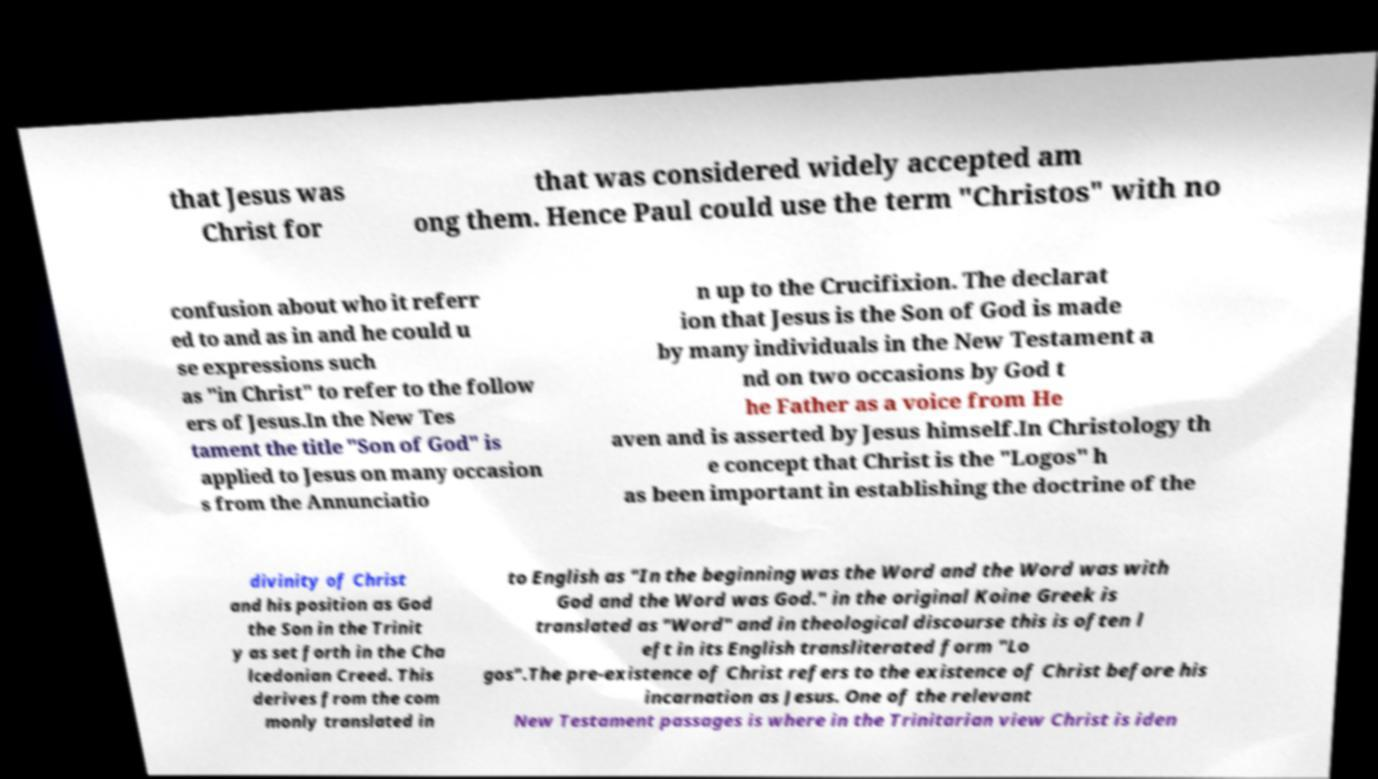For documentation purposes, I need the text within this image transcribed. Could you provide that? that Jesus was Christ for that was considered widely accepted am ong them. Hence Paul could use the term "Christos" with no confusion about who it referr ed to and as in and he could u se expressions such as "in Christ" to refer to the follow ers of Jesus.In the New Tes tament the title "Son of God" is applied to Jesus on many occasion s from the Annunciatio n up to the Crucifixion. The declarat ion that Jesus is the Son of God is made by many individuals in the New Testament a nd on two occasions by God t he Father as a voice from He aven and is asserted by Jesus himself.In Christology th e concept that Christ is the "Logos" h as been important in establishing the doctrine of the divinity of Christ and his position as God the Son in the Trinit y as set forth in the Cha lcedonian Creed. This derives from the com monly translated in to English as "In the beginning was the Word and the Word was with God and the Word was God." in the original Koine Greek is translated as "Word" and in theological discourse this is often l eft in its English transliterated form "Lo gos".The pre-existence of Christ refers to the existence of Christ before his incarnation as Jesus. One of the relevant New Testament passages is where in the Trinitarian view Christ is iden 